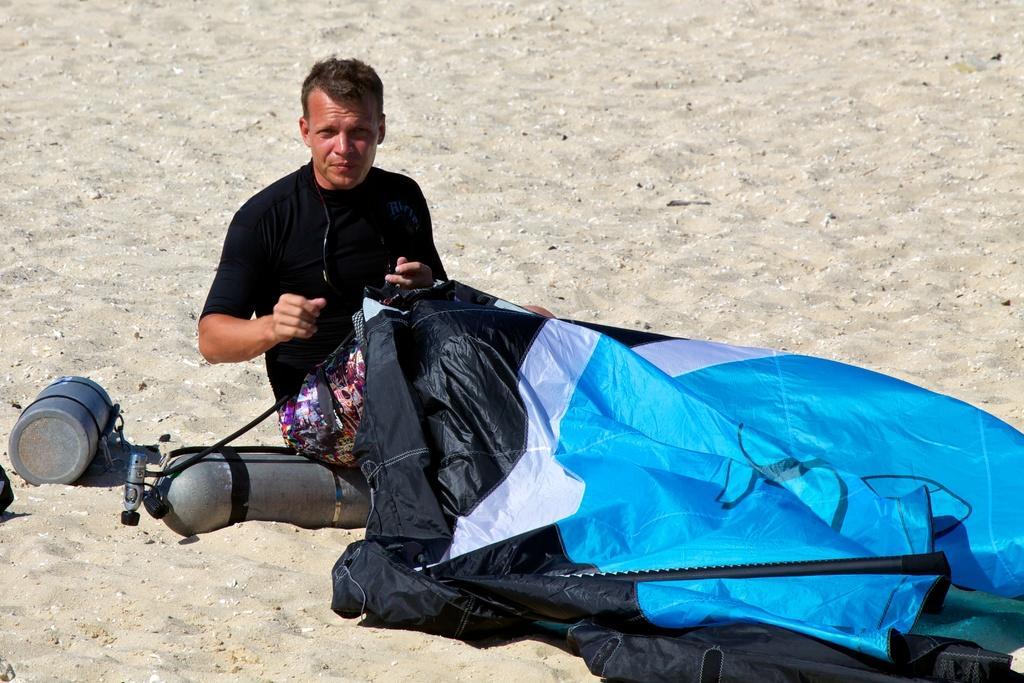In one or two sentences, can you explain what this image depicts? In this picture there is a man who is wearing black dress. He is sitting near to the cylinders and cover. At the we can see the sand. 